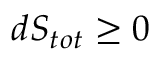<formula> <loc_0><loc_0><loc_500><loc_500>d S _ { t o t } \geq 0</formula> 